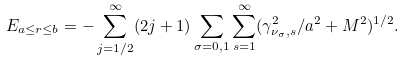Convert formula to latex. <formula><loc_0><loc_0><loc_500><loc_500>E _ { a \leq r \leq b } = - \sum _ { j = 1 / 2 } ^ { \infty } ( 2 j + 1 ) \sum _ { \sigma = 0 , 1 } \sum _ { s = 1 } ^ { \infty } ( \gamma _ { \nu _ { \sigma } , s } ^ { 2 } / a ^ { 2 } + M ^ { 2 } ) ^ { 1 / 2 } .</formula> 